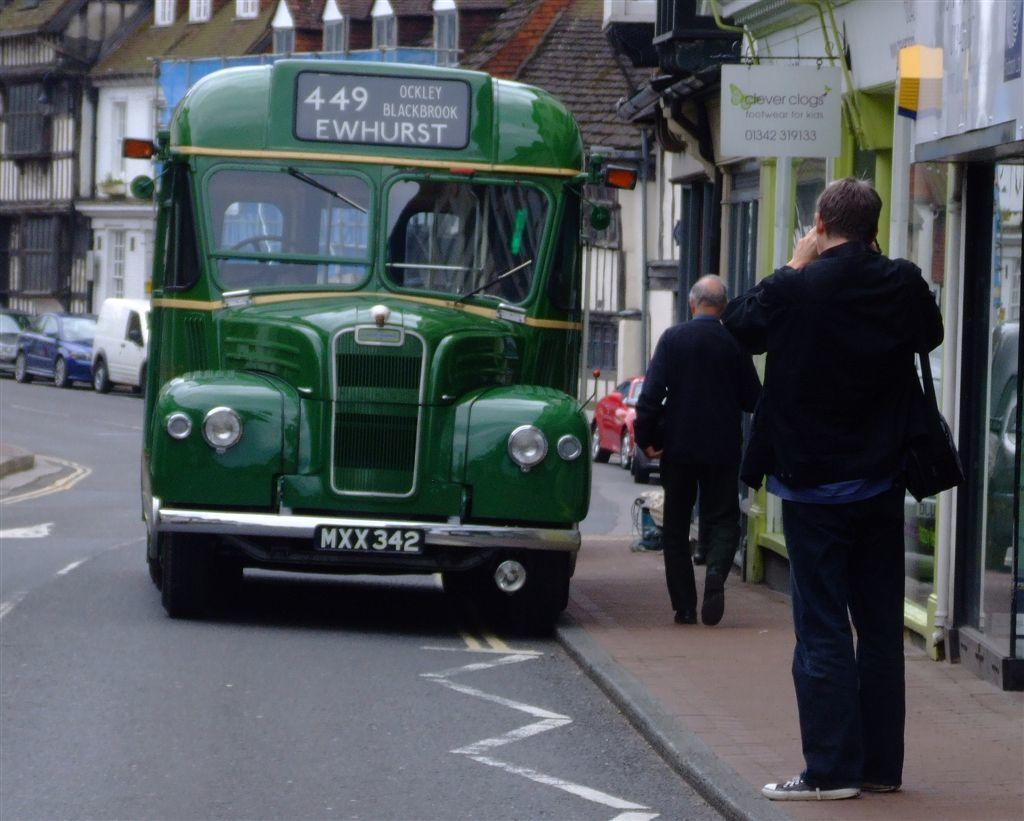<image>
Render a clear and concise summary of the photo. A green bus with license plate MXX 342 on a city street. 